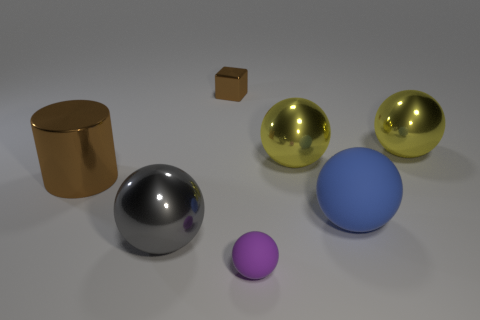How many big metallic things are the same color as the tiny metallic object?
Give a very brief answer. 1. Is the size of the metallic sphere that is in front of the cylinder the same as the brown metal object right of the large brown object?
Provide a short and direct response. No. Is the size of the brown metallic cube the same as the ball right of the blue object?
Your answer should be compact. No. What size is the blue matte thing?
Offer a very short reply. Large. There is a block that is the same material as the cylinder; what is its color?
Your answer should be compact. Brown. How many large red blocks are made of the same material as the purple sphere?
Provide a short and direct response. 0. How many things are either blue balls or big metallic things on the right side of the gray ball?
Make the answer very short. 3. Is the small brown object behind the gray ball made of the same material as the small sphere?
Ensure brevity in your answer.  No. The rubber object that is the same size as the brown metal cylinder is what color?
Ensure brevity in your answer.  Blue. Are there any large gray shiny things of the same shape as the tiny metal thing?
Ensure brevity in your answer.  No. 